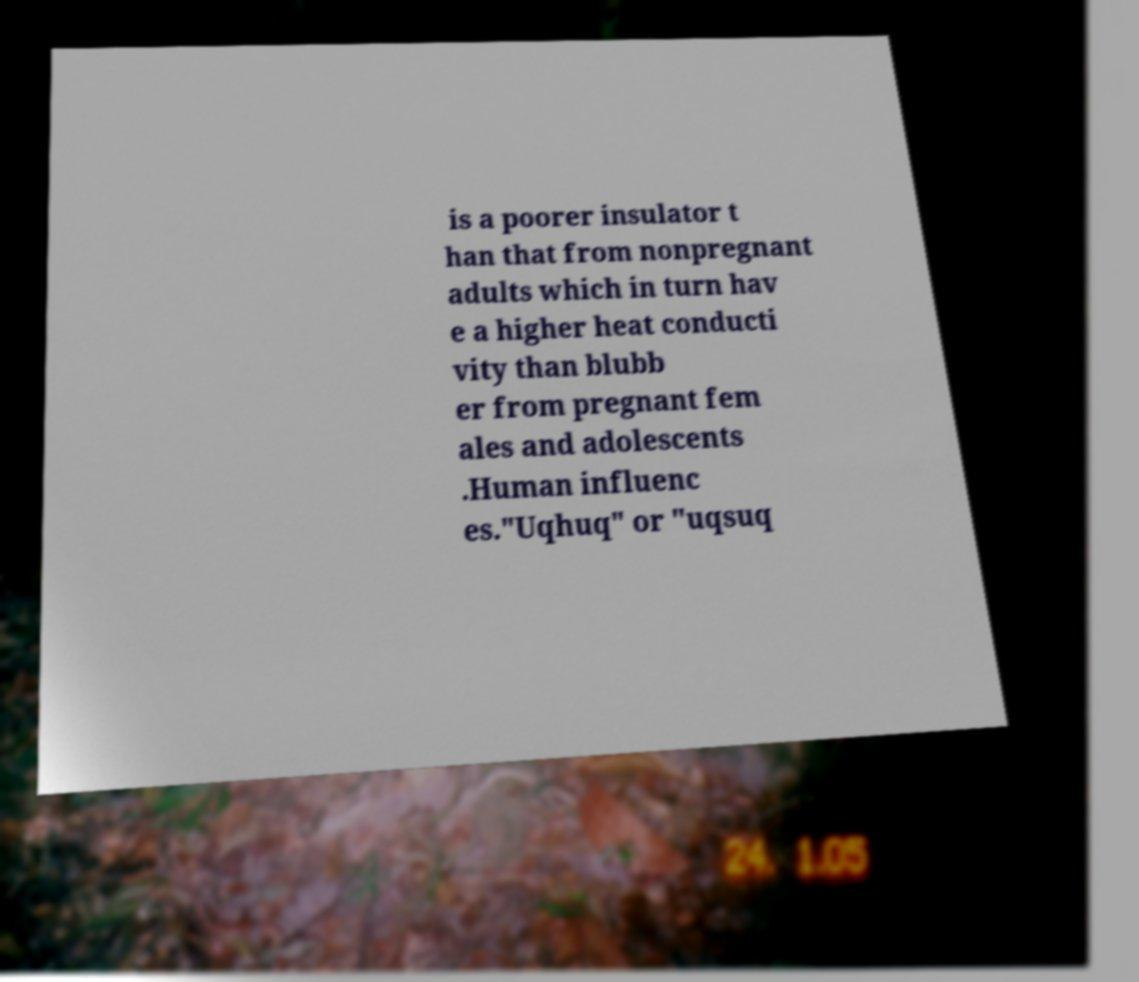Could you assist in decoding the text presented in this image and type it out clearly? is a poorer insulator t han that from nonpregnant adults which in turn hav e a higher heat conducti vity than blubb er from pregnant fem ales and adolescents .Human influenc es."Uqhuq" or "uqsuq 